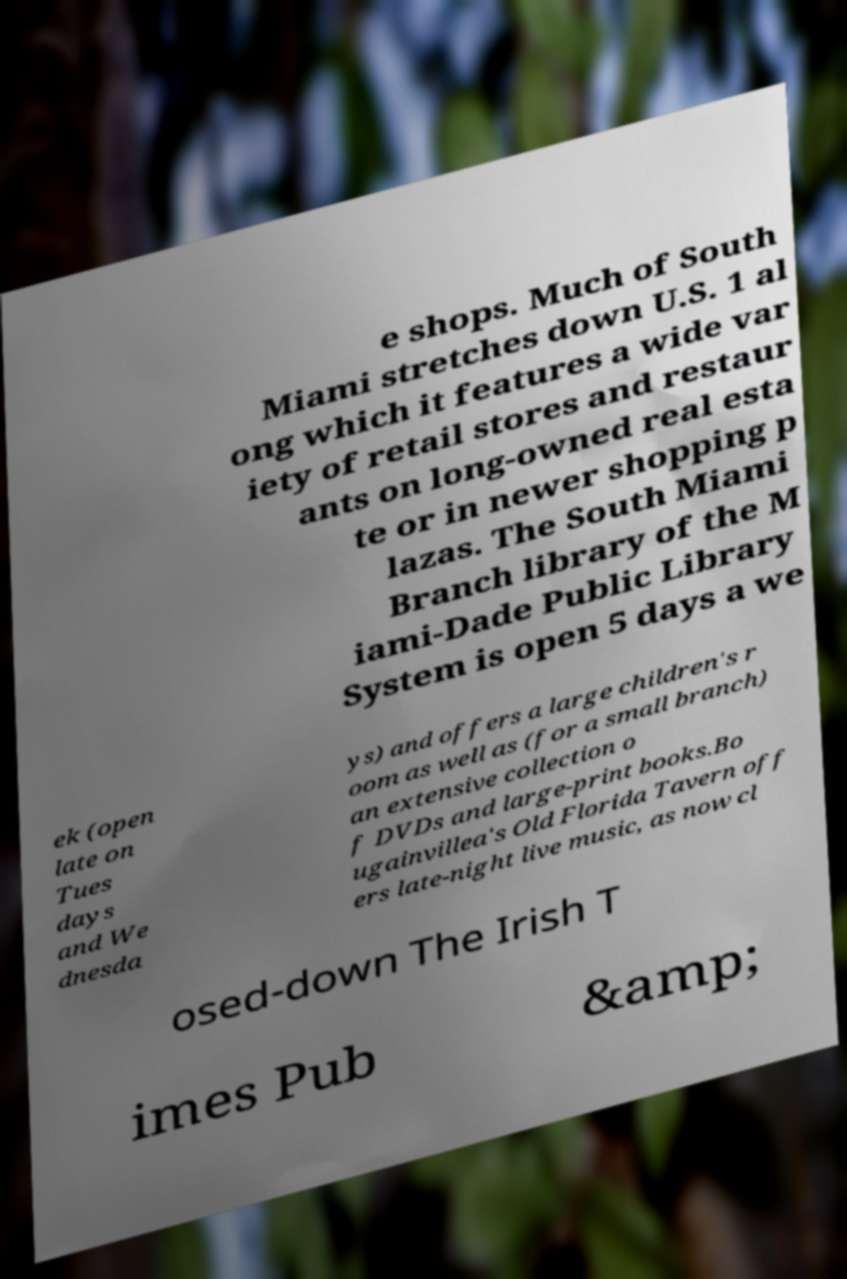There's text embedded in this image that I need extracted. Can you transcribe it verbatim? e shops. Much of South Miami stretches down U.S. 1 al ong which it features a wide var iety of retail stores and restaur ants on long-owned real esta te or in newer shopping p lazas. The South Miami Branch library of the M iami-Dade Public Library System is open 5 days a we ek (open late on Tues days and We dnesda ys) and offers a large children's r oom as well as (for a small branch) an extensive collection o f DVDs and large-print books.Bo ugainvillea's Old Florida Tavern off ers late-night live music, as now cl osed-down The Irish T imes Pub &amp; 